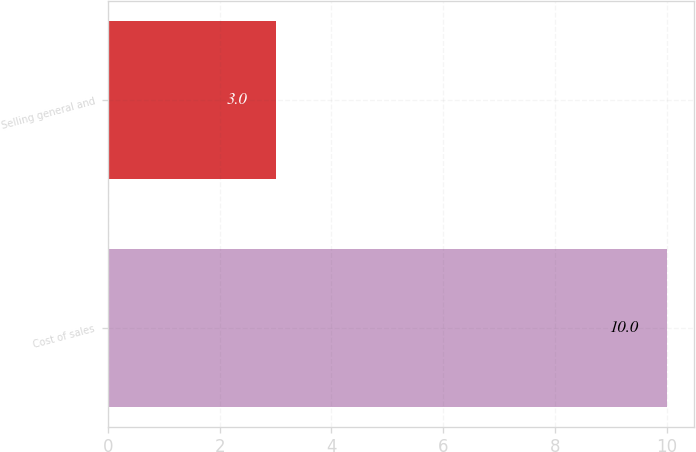Convert chart to OTSL. <chart><loc_0><loc_0><loc_500><loc_500><bar_chart><fcel>Cost of sales<fcel>Selling general and<nl><fcel>10<fcel>3<nl></chart> 